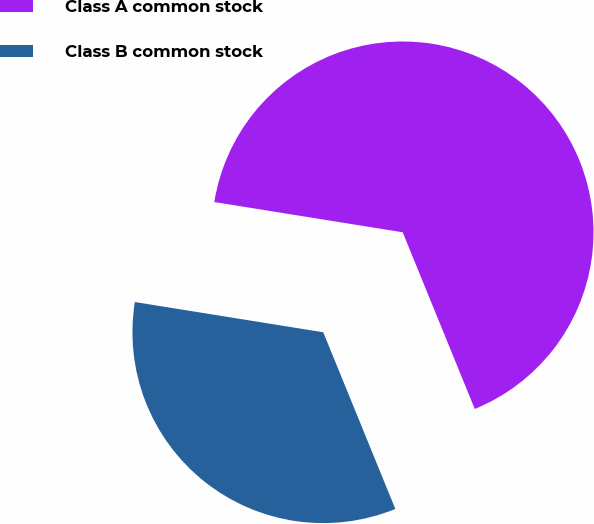<chart> <loc_0><loc_0><loc_500><loc_500><pie_chart><fcel>Class A common stock<fcel>Class B common stock<nl><fcel>66.3%<fcel>33.7%<nl></chart> 